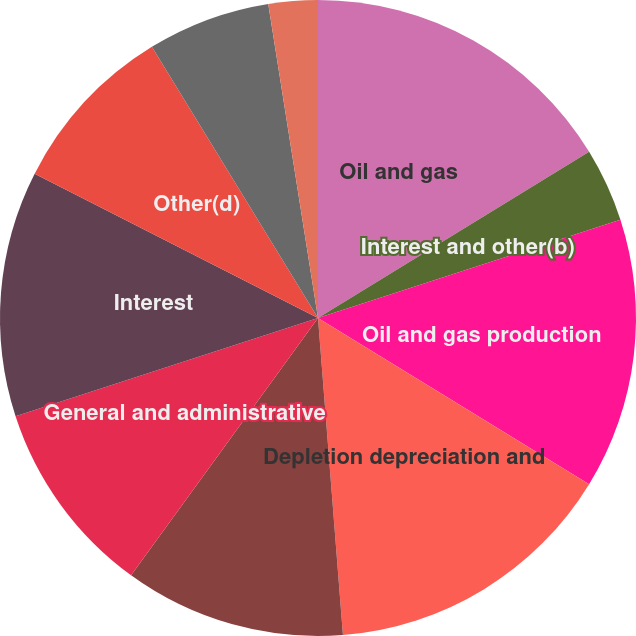Convert chart. <chart><loc_0><loc_0><loc_500><loc_500><pie_chart><fcel>Oil and gas<fcel>Interest and other(b)<fcel>Oil and gas production<fcel>Depletion depreciation and<fcel>Exploration and abandonments<fcel>General and administrative<fcel>Interest<fcel>Other(d)<fcel>Income from continuing<fcel>Income tax benefit<nl><fcel>16.25%<fcel>3.75%<fcel>13.75%<fcel>15.0%<fcel>11.25%<fcel>10.0%<fcel>12.5%<fcel>8.75%<fcel>6.25%<fcel>2.5%<nl></chart> 